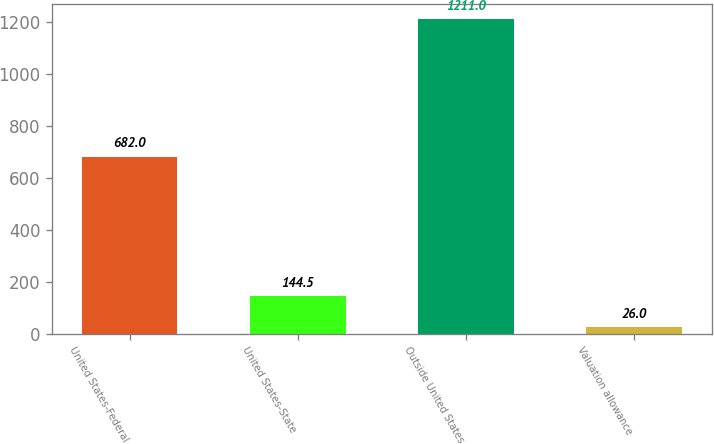<chart> <loc_0><loc_0><loc_500><loc_500><bar_chart><fcel>United States-Federal<fcel>United States-State<fcel>Outside United States<fcel>Valuation allowance<nl><fcel>682<fcel>144.5<fcel>1211<fcel>26<nl></chart> 